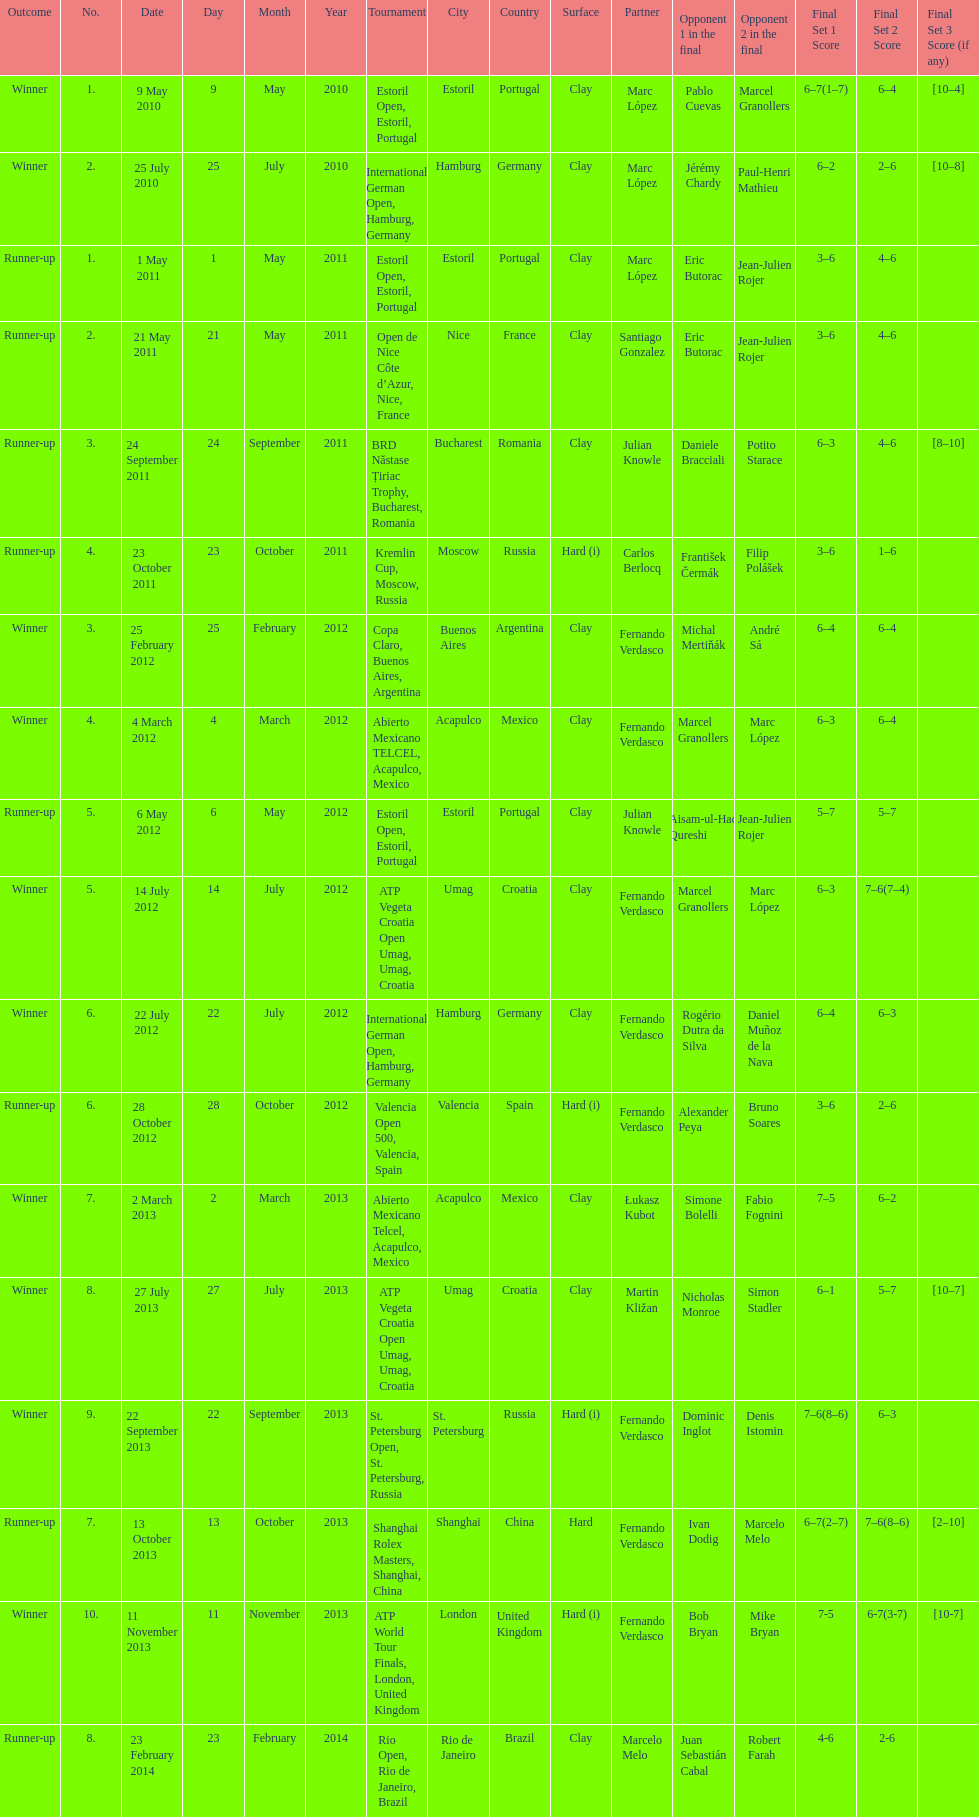What tournament was played after the kremlin cup? Copa Claro, Buenos Aires, Argentina. 